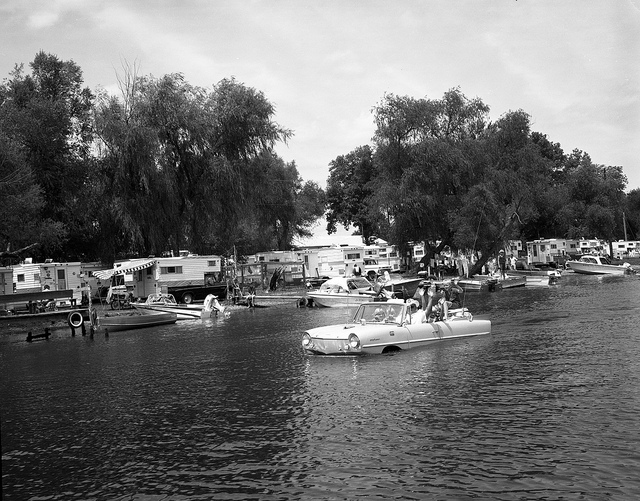<image>Why is the car in the water? I don't know why the car is in the water, it could be due to flooding or it could float like a boat. Why is the car in the water? The reason why the car is in the water is unclear. It can be due to flooding or maybe the car can float. 